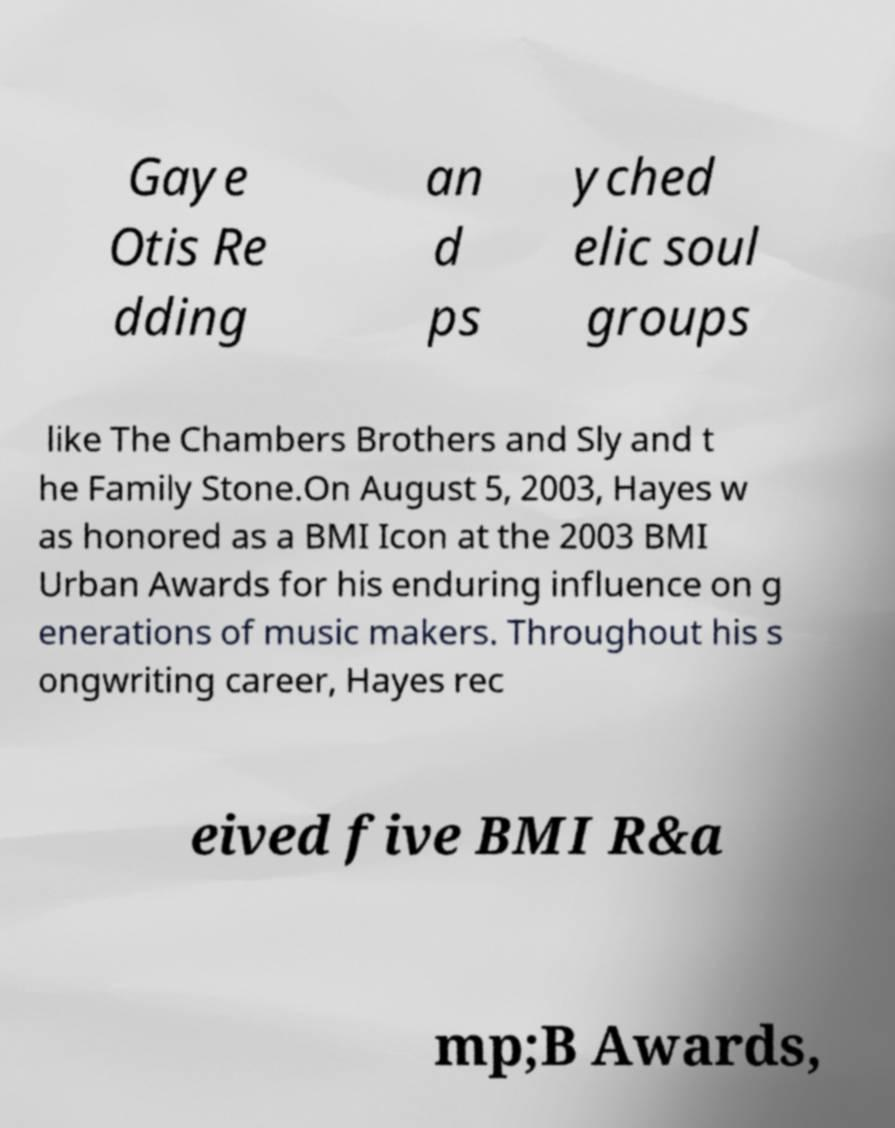Please read and relay the text visible in this image. What does it say? Gaye Otis Re dding an d ps yched elic soul groups like The Chambers Brothers and Sly and t he Family Stone.On August 5, 2003, Hayes w as honored as a BMI Icon at the 2003 BMI Urban Awards for his enduring influence on g enerations of music makers. Throughout his s ongwriting career, Hayes rec eived five BMI R&a mp;B Awards, 